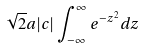Convert formula to latex. <formula><loc_0><loc_0><loc_500><loc_500>\sqrt { 2 } a | c | \int _ { - \infty } ^ { \infty } e ^ { - z ^ { 2 } } d z</formula> 